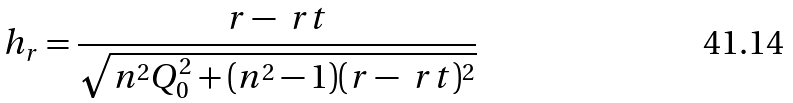Convert formula to latex. <formula><loc_0><loc_0><loc_500><loc_500>h _ { r } = \frac { r - \ r t } { \sqrt { n ^ { 2 } Q _ { 0 } ^ { 2 } + ( n ^ { 2 } - 1 ) ( r - \ r t ) ^ { 2 } } }</formula> 